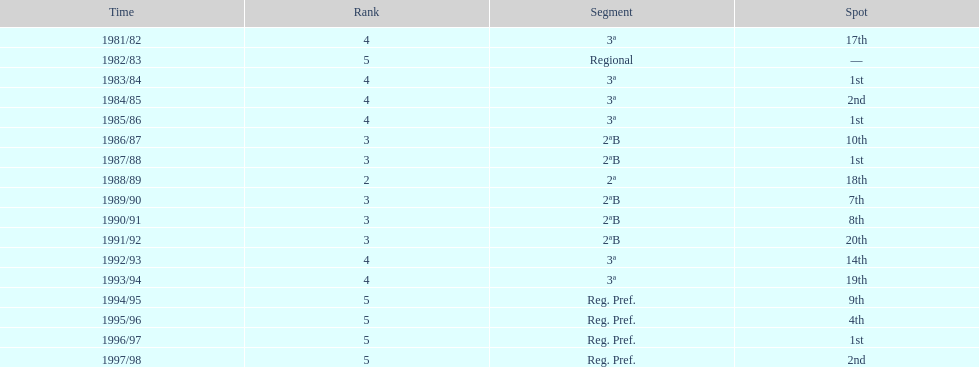How many years were they in tier 3 5. 